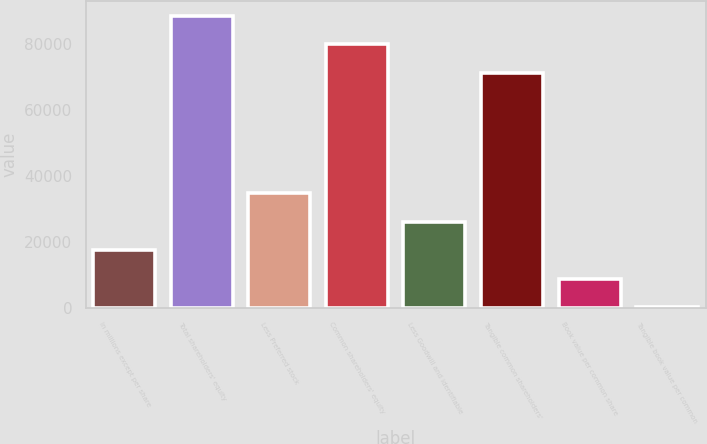Convert chart. <chart><loc_0><loc_0><loc_500><loc_500><bar_chart><fcel>in millions except per share<fcel>Total shareholders' equity<fcel>Less Preferred stock<fcel>Common shareholders' equity<fcel>Less Goodwill and identifiable<fcel>Tangible common shareholders'<fcel>Book value per common share<fcel>Tangible book value per common<nl><fcel>17474.9<fcel>88693.3<fcel>34788.2<fcel>80036.6<fcel>26131.6<fcel>71380<fcel>8818.28<fcel>161.64<nl></chart> 